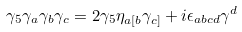<formula> <loc_0><loc_0><loc_500><loc_500>\gamma _ { 5 } \gamma _ { a } \gamma _ { b } \gamma _ { c } = 2 \gamma _ { 5 } \eta _ { a [ b } \gamma _ { c ] } + i \epsilon _ { a b c d } \gamma ^ { d }</formula> 